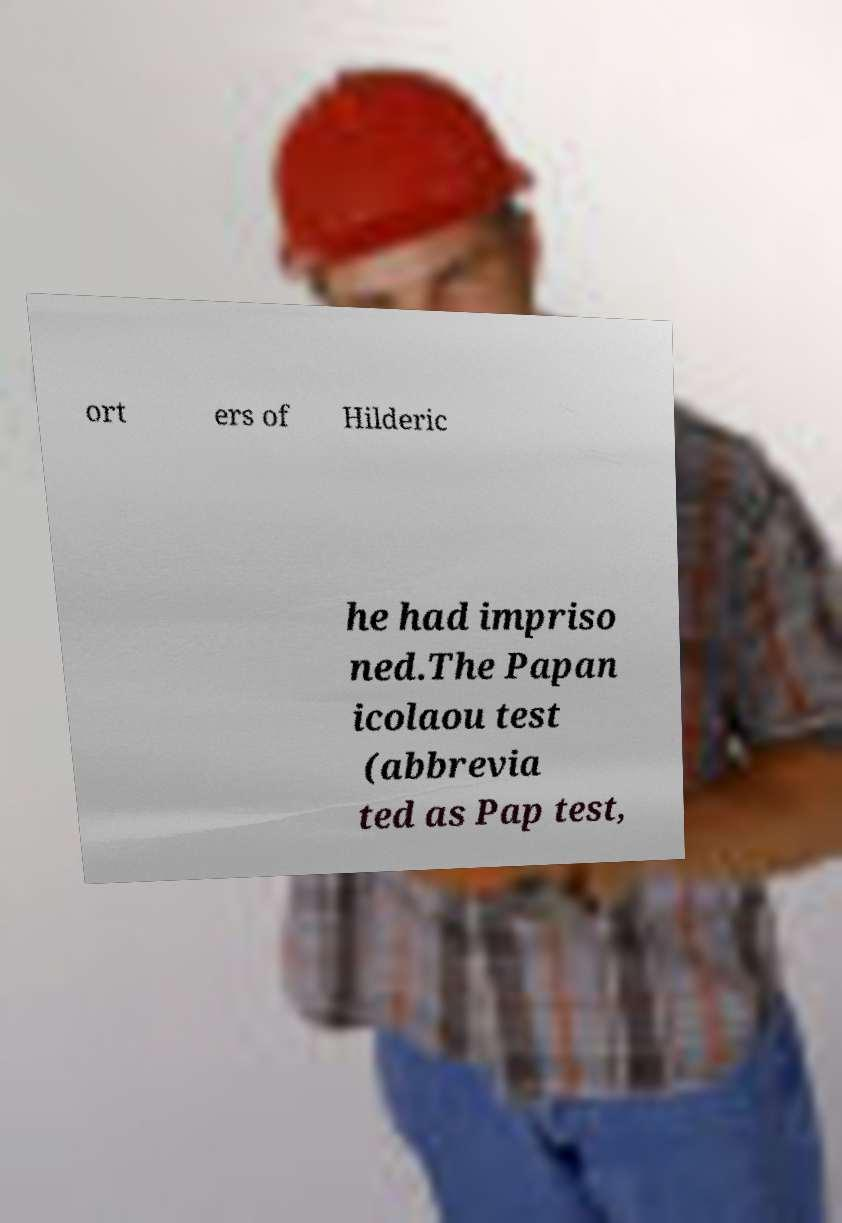There's text embedded in this image that I need extracted. Can you transcribe it verbatim? ort ers of Hilderic he had impriso ned.The Papan icolaou test (abbrevia ted as Pap test, 